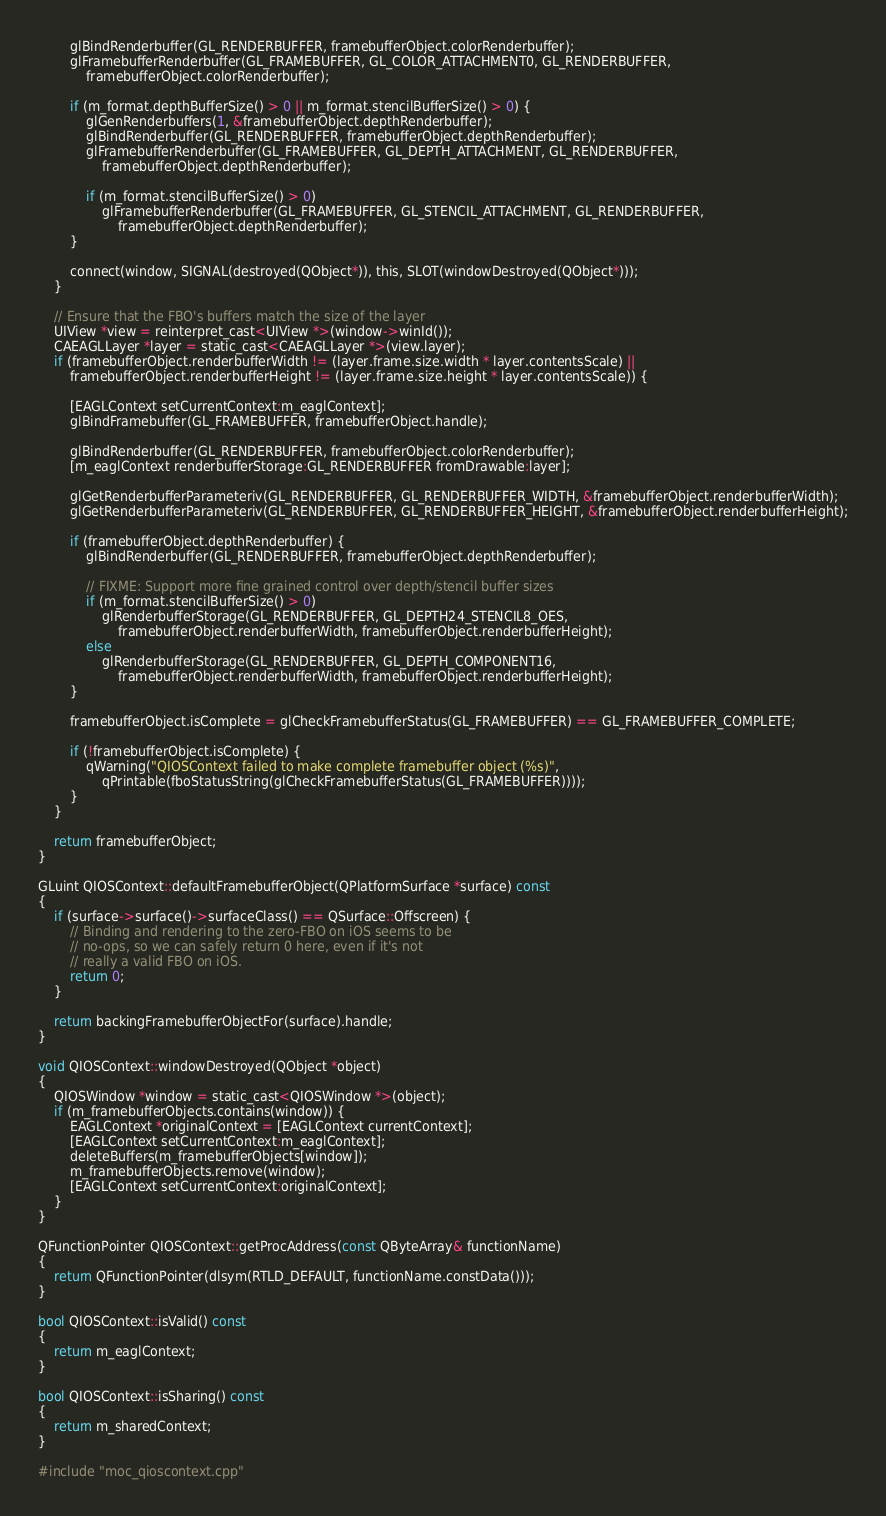<code> <loc_0><loc_0><loc_500><loc_500><_ObjectiveC_>        glBindRenderbuffer(GL_RENDERBUFFER, framebufferObject.colorRenderbuffer);
        glFramebufferRenderbuffer(GL_FRAMEBUFFER, GL_COLOR_ATTACHMENT0, GL_RENDERBUFFER,
            framebufferObject.colorRenderbuffer);

        if (m_format.depthBufferSize() > 0 || m_format.stencilBufferSize() > 0) {
            glGenRenderbuffers(1, &framebufferObject.depthRenderbuffer);
            glBindRenderbuffer(GL_RENDERBUFFER, framebufferObject.depthRenderbuffer);
            glFramebufferRenderbuffer(GL_FRAMEBUFFER, GL_DEPTH_ATTACHMENT, GL_RENDERBUFFER,
                framebufferObject.depthRenderbuffer);

            if (m_format.stencilBufferSize() > 0)
                glFramebufferRenderbuffer(GL_FRAMEBUFFER, GL_STENCIL_ATTACHMENT, GL_RENDERBUFFER,
                    framebufferObject.depthRenderbuffer);
        }

        connect(window, SIGNAL(destroyed(QObject*)), this, SLOT(windowDestroyed(QObject*)));
    }

    // Ensure that the FBO's buffers match the size of the layer
    UIView *view = reinterpret_cast<UIView *>(window->winId());
    CAEAGLLayer *layer = static_cast<CAEAGLLayer *>(view.layer);
    if (framebufferObject.renderbufferWidth != (layer.frame.size.width * layer.contentsScale) ||
        framebufferObject.renderbufferHeight != (layer.frame.size.height * layer.contentsScale)) {

        [EAGLContext setCurrentContext:m_eaglContext];
        glBindFramebuffer(GL_FRAMEBUFFER, framebufferObject.handle);

        glBindRenderbuffer(GL_RENDERBUFFER, framebufferObject.colorRenderbuffer);
        [m_eaglContext renderbufferStorage:GL_RENDERBUFFER fromDrawable:layer];

        glGetRenderbufferParameteriv(GL_RENDERBUFFER, GL_RENDERBUFFER_WIDTH, &framebufferObject.renderbufferWidth);
        glGetRenderbufferParameteriv(GL_RENDERBUFFER, GL_RENDERBUFFER_HEIGHT, &framebufferObject.renderbufferHeight);

        if (framebufferObject.depthRenderbuffer) {
            glBindRenderbuffer(GL_RENDERBUFFER, framebufferObject.depthRenderbuffer);

            // FIXME: Support more fine grained control over depth/stencil buffer sizes
            if (m_format.stencilBufferSize() > 0)
                glRenderbufferStorage(GL_RENDERBUFFER, GL_DEPTH24_STENCIL8_OES,
                    framebufferObject.renderbufferWidth, framebufferObject.renderbufferHeight);
            else
                glRenderbufferStorage(GL_RENDERBUFFER, GL_DEPTH_COMPONENT16,
                    framebufferObject.renderbufferWidth, framebufferObject.renderbufferHeight);
        }

        framebufferObject.isComplete = glCheckFramebufferStatus(GL_FRAMEBUFFER) == GL_FRAMEBUFFER_COMPLETE;

        if (!framebufferObject.isComplete) {
            qWarning("QIOSContext failed to make complete framebuffer object (%s)",
                qPrintable(fboStatusString(glCheckFramebufferStatus(GL_FRAMEBUFFER))));
        }
    }

    return framebufferObject;
}

GLuint QIOSContext::defaultFramebufferObject(QPlatformSurface *surface) const
{
    if (surface->surface()->surfaceClass() == QSurface::Offscreen) {
        // Binding and rendering to the zero-FBO on iOS seems to be
        // no-ops, so we can safely return 0 here, even if it's not
        // really a valid FBO on iOS.
        return 0;
    }

    return backingFramebufferObjectFor(surface).handle;
}

void QIOSContext::windowDestroyed(QObject *object)
{
    QIOSWindow *window = static_cast<QIOSWindow *>(object);
    if (m_framebufferObjects.contains(window)) {
        EAGLContext *originalContext = [EAGLContext currentContext];
        [EAGLContext setCurrentContext:m_eaglContext];
        deleteBuffers(m_framebufferObjects[window]);
        m_framebufferObjects.remove(window);
        [EAGLContext setCurrentContext:originalContext];
    }
}

QFunctionPointer QIOSContext::getProcAddress(const QByteArray& functionName)
{
    return QFunctionPointer(dlsym(RTLD_DEFAULT, functionName.constData()));
}

bool QIOSContext::isValid() const
{
    return m_eaglContext;
}

bool QIOSContext::isSharing() const
{
    return m_sharedContext;
}

#include "moc_qioscontext.cpp"

</code> 